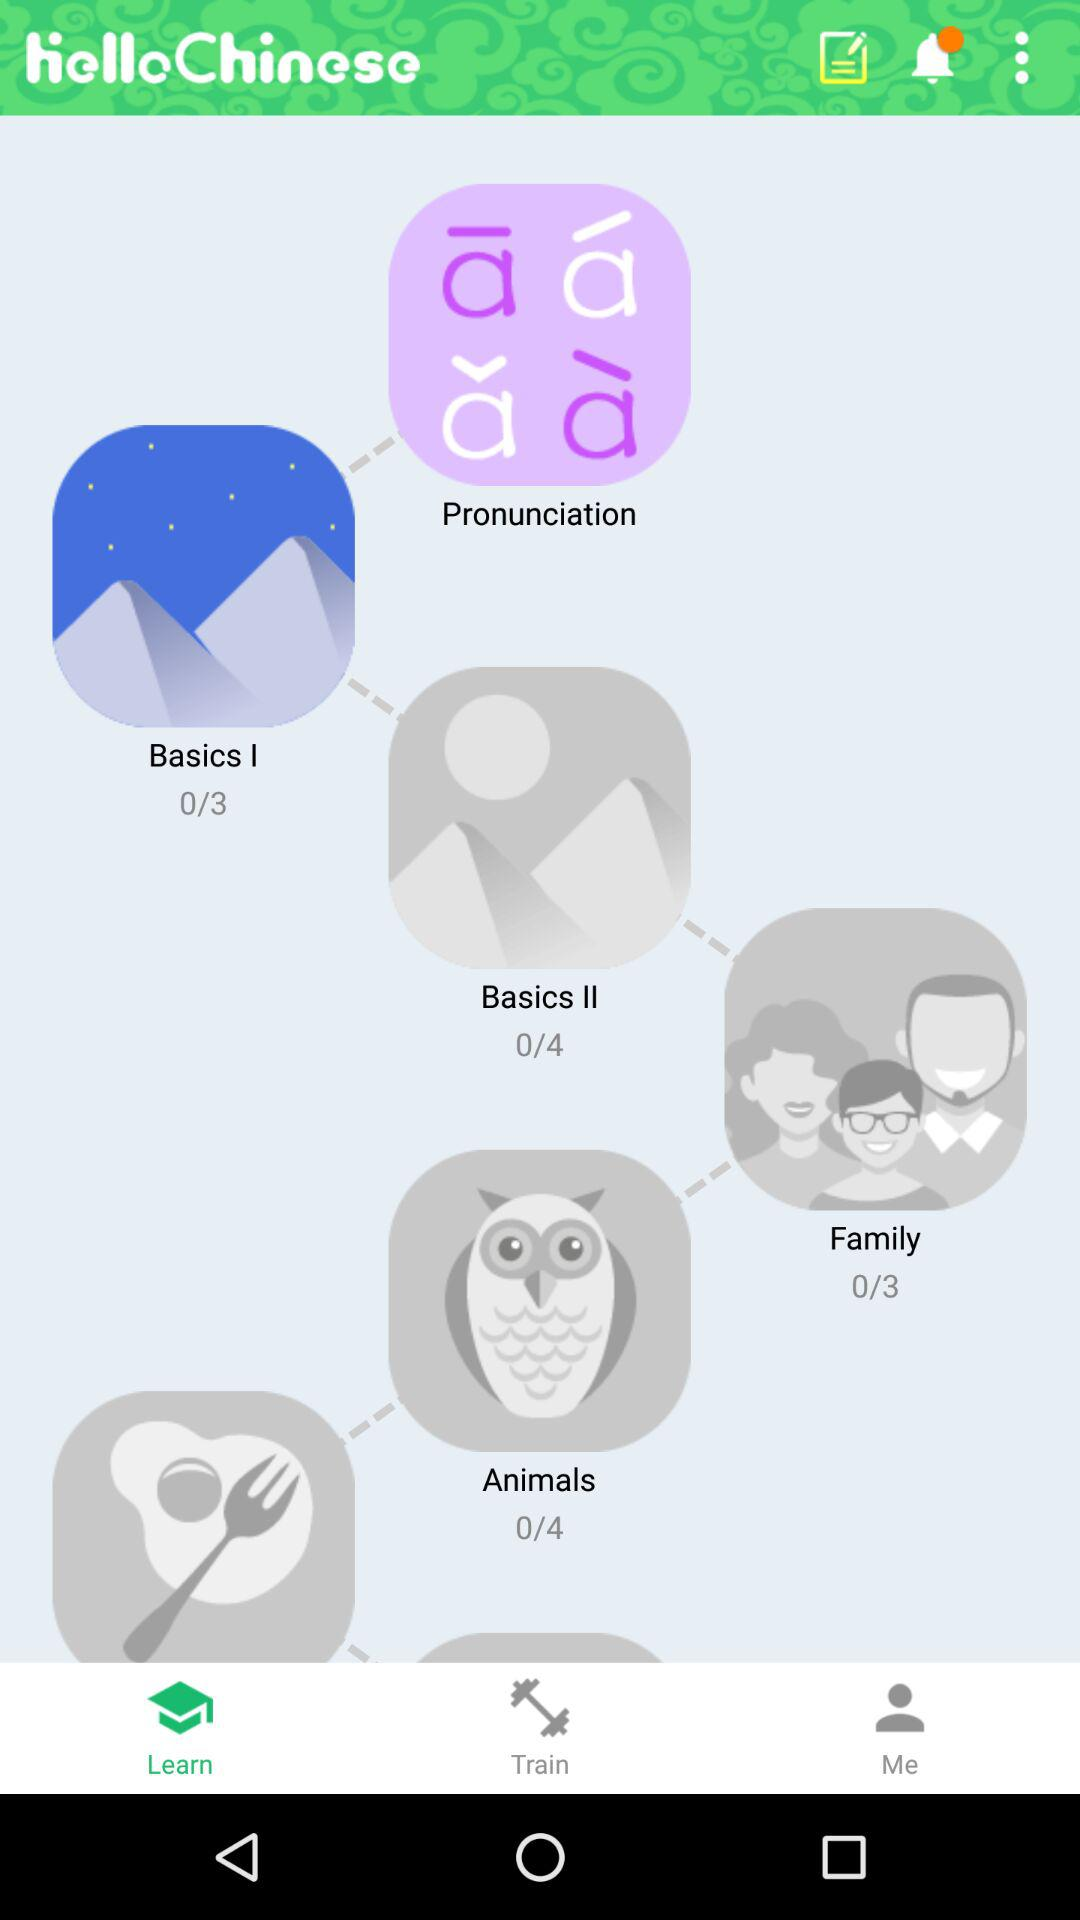How many lessons are in "Basics II"? There are 4 lessons in "Basics II". 